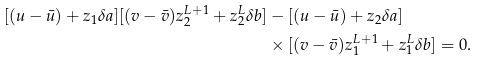Convert formula to latex. <formula><loc_0><loc_0><loc_500><loc_500>[ ( u - \bar { u } ) + z _ { 1 } \delta a ] [ ( v - \bar { v } ) z _ { 2 } ^ { L + 1 } + z _ { 2 } ^ { L } \delta b ] & - [ ( u - \bar { u } ) + z _ { 2 } \delta a ] \\ & \times [ ( v - \bar { v } ) z _ { 1 } ^ { L + 1 } + z _ { 1 } ^ { L } \delta b ] = 0 .</formula> 